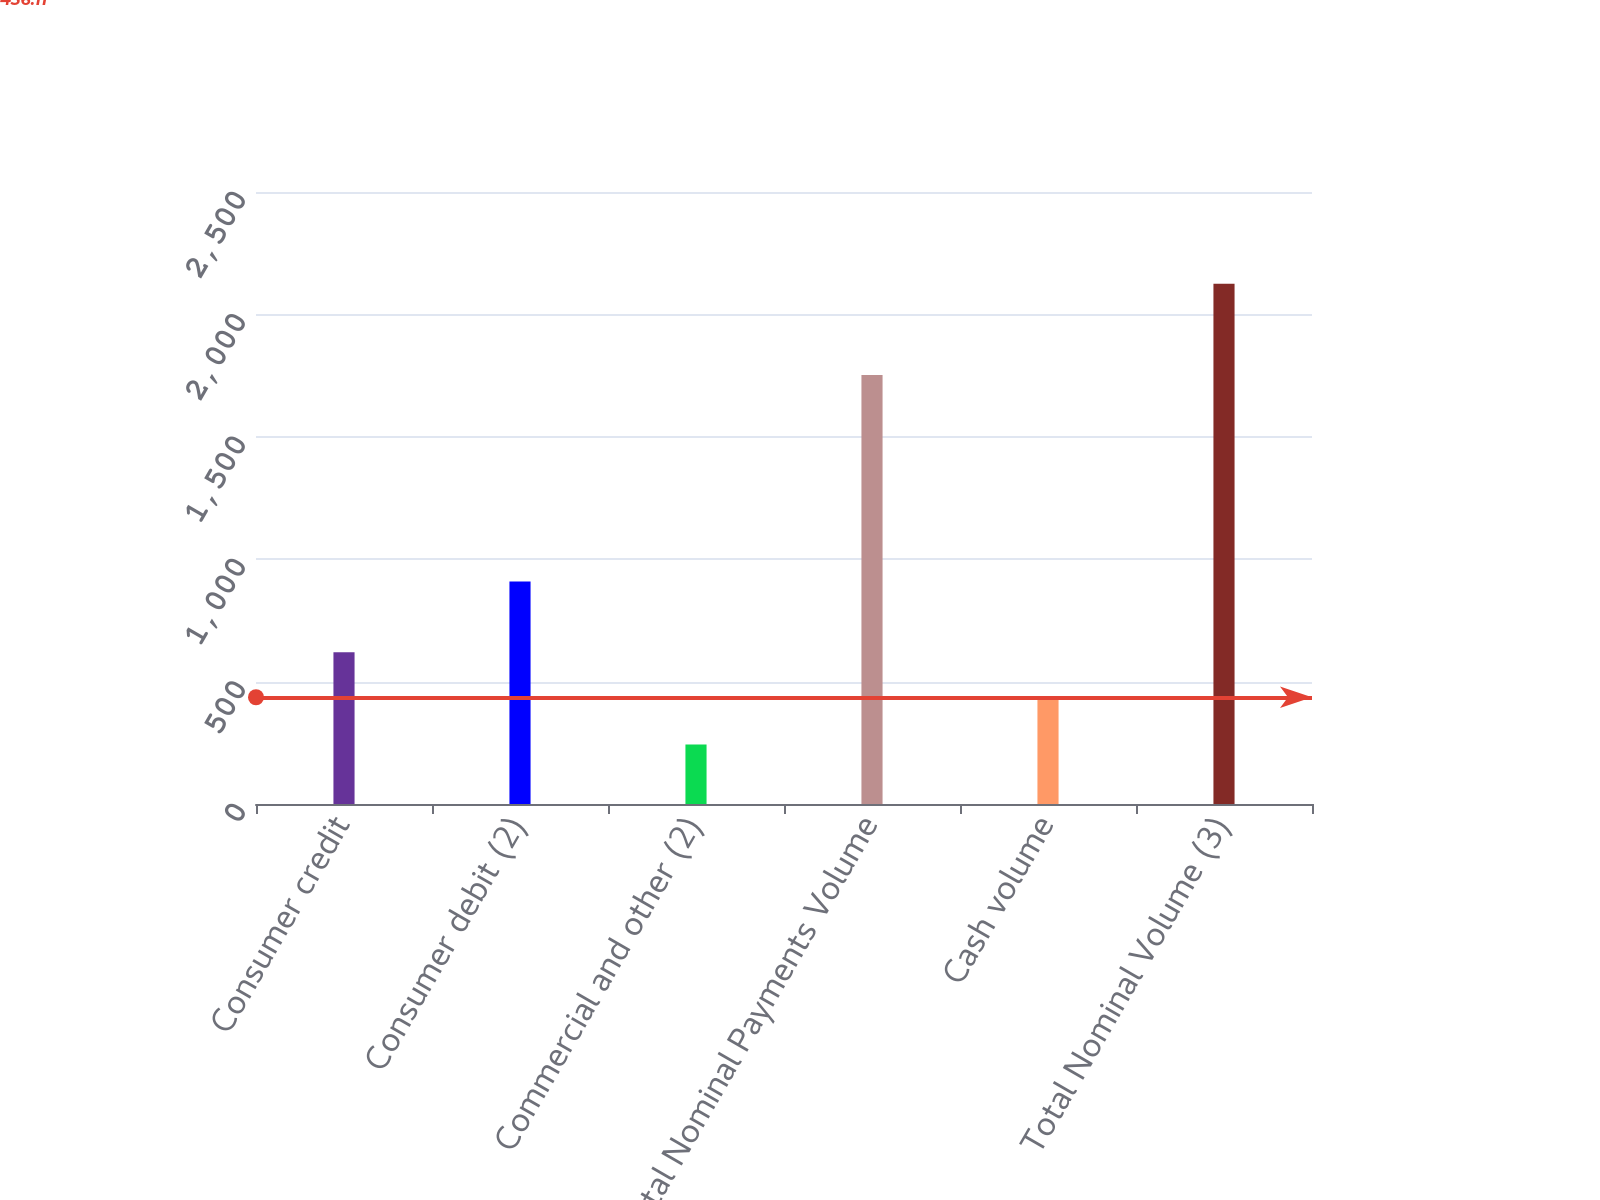Convert chart to OTSL. <chart><loc_0><loc_0><loc_500><loc_500><bar_chart><fcel>Consumer credit<fcel>Consumer debit (2)<fcel>Commercial and other (2)<fcel>Total Nominal Payments Volume<fcel>Cash volume<fcel>Total Nominal Volume (3)<nl><fcel>619.4<fcel>909<fcel>243<fcel>1752<fcel>431.2<fcel>2125<nl></chart> 